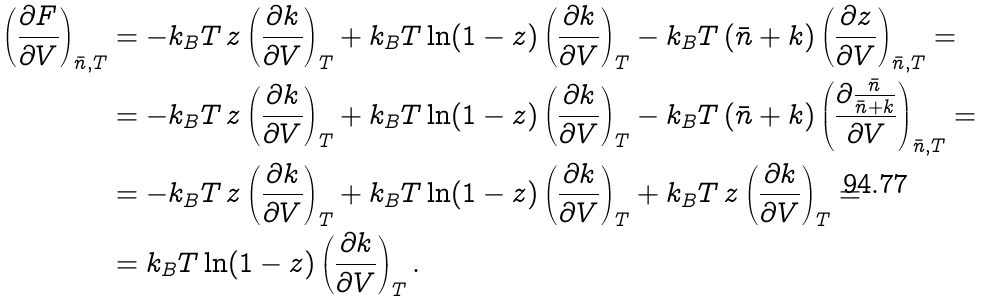Convert formula to latex. <formula><loc_0><loc_0><loc_500><loc_500>\left ( \frac { \partial F } { \partial V } \right ) _ { \bar { n } , T } & = - k _ { B } T \, z \left ( \frac { \partial k } { \partial V } \right ) _ { T } + k _ { B } T \ln ( 1 - z ) \left ( \frac { \partial k } { \partial V } \right ) _ { T } - k _ { B } T \, ( \bar { n } + k ) \left ( \frac { \partial z } { \partial V } \right ) _ { \bar { n } , T } = \\ & = - k _ { B } T \, z \left ( \frac { \partial k } { \partial V } \right ) _ { T } + k _ { B } T \ln ( 1 - z ) \left ( \frac { \partial k } { \partial V } \right ) _ { T } - k _ { B } T \, ( \bar { n } + k ) \left ( \frac { \partial \frac { \bar { n } } { \bar { n } + k } } { \partial V } \right ) _ { \bar { n } , T } = \\ & = - k _ { B } T \, z \left ( \frac { \partial k } { \partial V } \right ) _ { T } + k _ { B } T \ln ( 1 - z ) \left ( \frac { \partial k } { \partial V } \right ) _ { T } + k _ { B } T \, z \left ( \frac { \partial k } { \partial V } \right ) _ { T } = \\ & = k _ { B } T \ln ( 1 - z ) \left ( \frac { \partial k } { \partial V } \right ) _ { T } .</formula> 